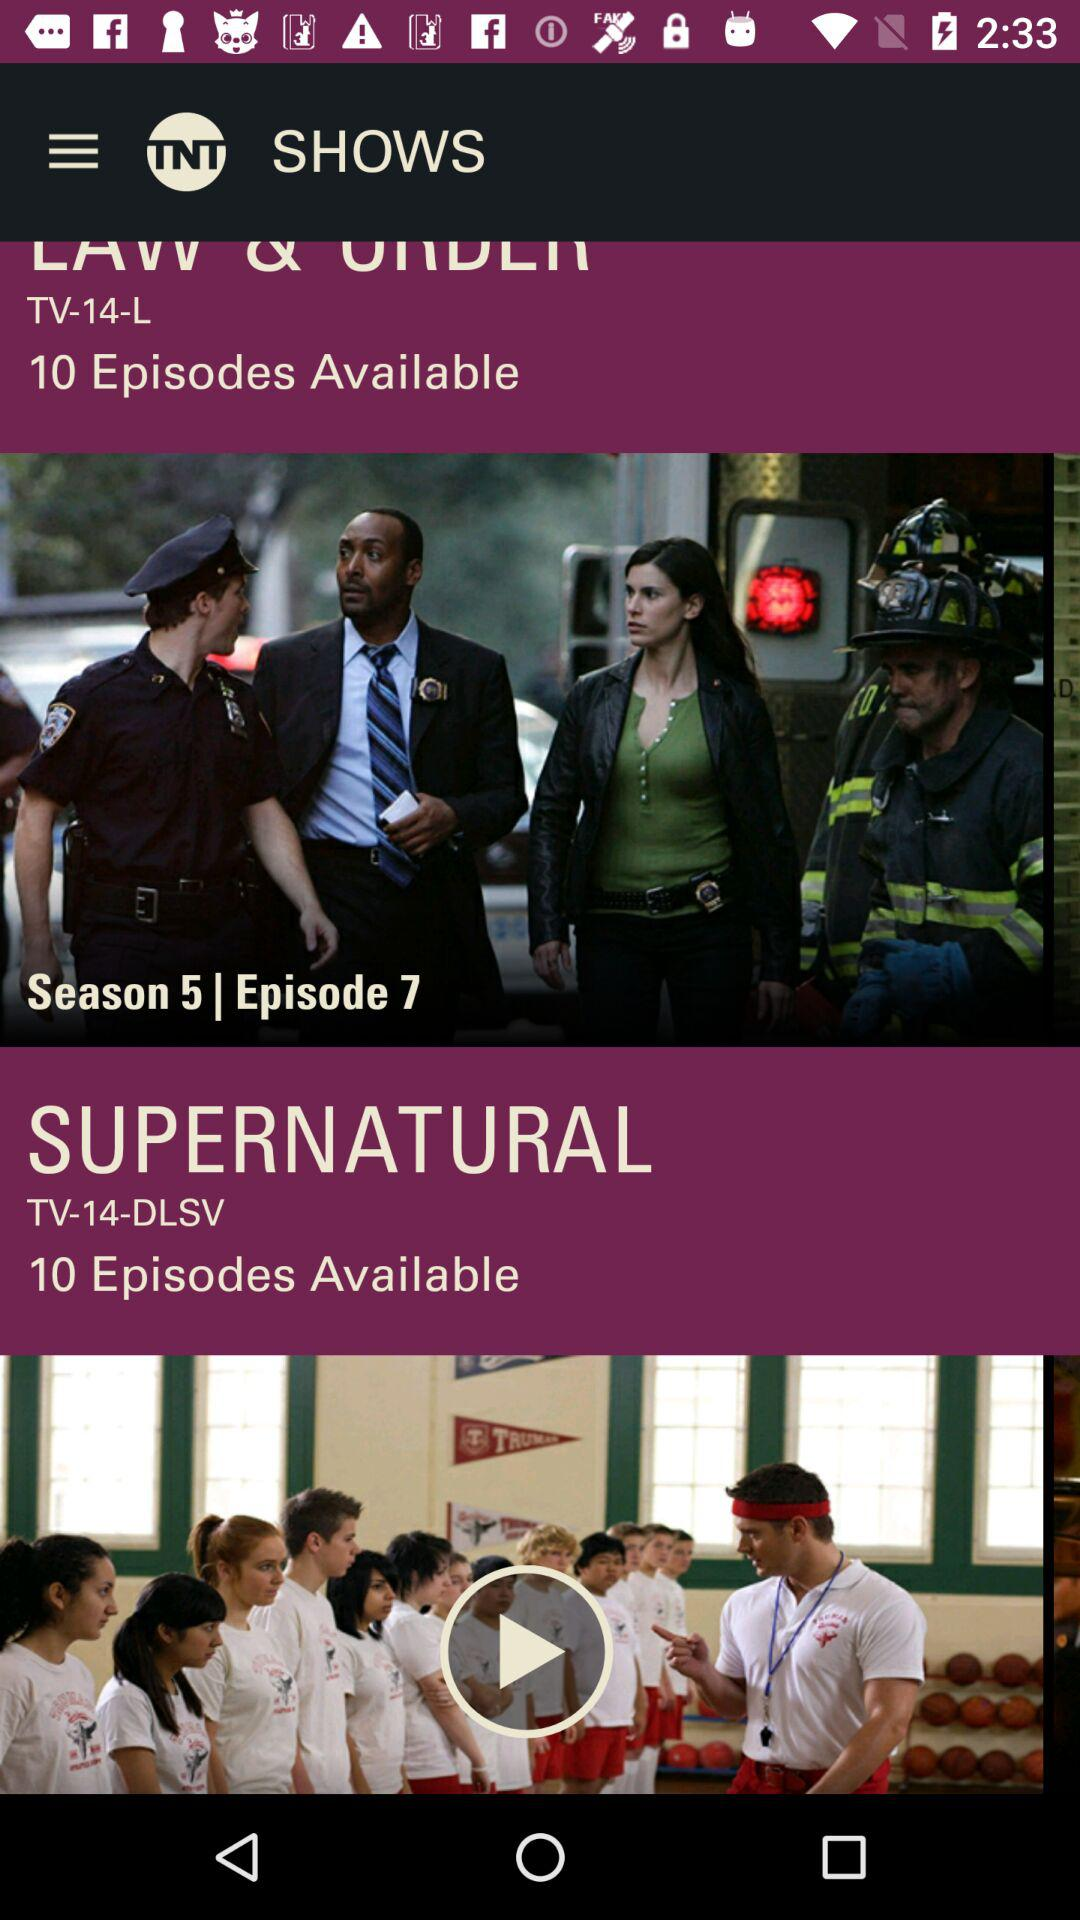What season and episode is the user watching of "SUPERNATURAL"?
When the provided information is insufficient, respond with <no answer>. <no answer> 